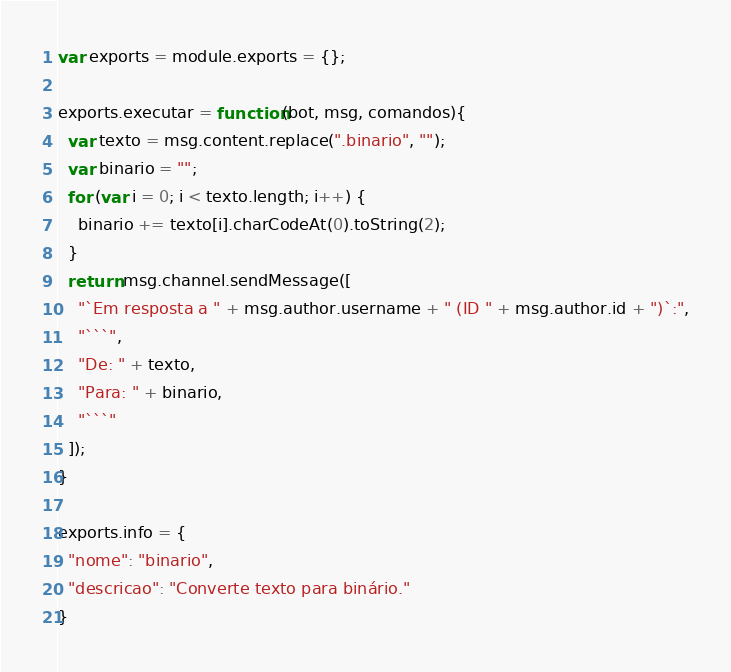<code> <loc_0><loc_0><loc_500><loc_500><_JavaScript_>var exports = module.exports = {};

exports.executar = function(bot, msg, comandos){
  var texto = msg.content.replace(".binario", "");
  var binario = "";
  for (var i = 0; i < texto.length; i++) {
    binario += texto[i].charCodeAt(0).toString(2);
  }
  return msg.channel.sendMessage([
    "`Em resposta a " + msg.author.username + " (ID " + msg.author.id + ")`:",
    "```",
    "De: " + texto,
    "Para: " + binario,
    "```"
  ]);
}

exports.info = {
  "nome": "binario",
  "descricao": "Converte texto para binário."
}
</code> 